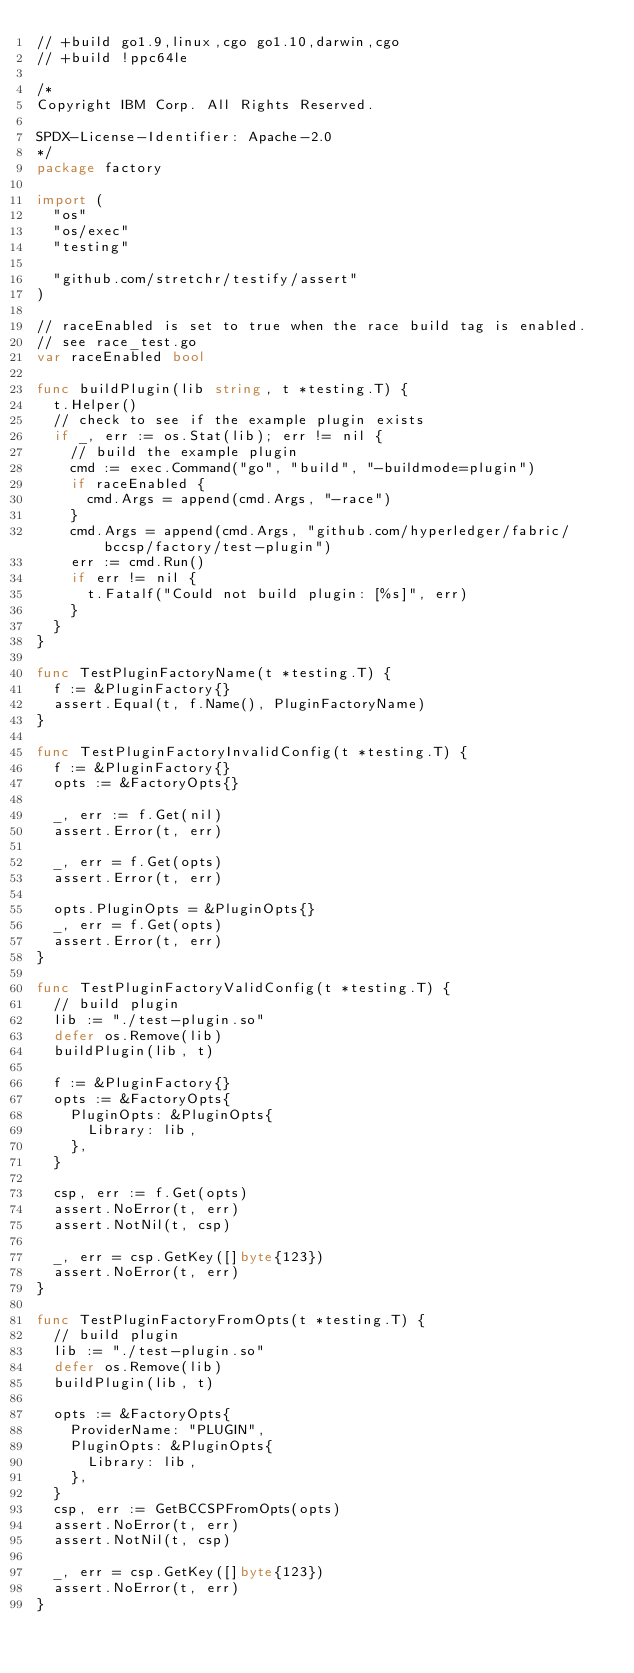<code> <loc_0><loc_0><loc_500><loc_500><_Go_>// +build go1.9,linux,cgo go1.10,darwin,cgo
// +build !ppc64le

/*
Copyright IBM Corp. All Rights Reserved.

SPDX-License-Identifier: Apache-2.0
*/
package factory

import (
	"os"
	"os/exec"
	"testing"

	"github.com/stretchr/testify/assert"
)

// raceEnabled is set to true when the race build tag is enabled.
// see race_test.go
var raceEnabled bool

func buildPlugin(lib string, t *testing.T) {
	t.Helper()
	// check to see if the example plugin exists
	if _, err := os.Stat(lib); err != nil {
		// build the example plugin
		cmd := exec.Command("go", "build", "-buildmode=plugin")
		if raceEnabled {
			cmd.Args = append(cmd.Args, "-race")
		}
		cmd.Args = append(cmd.Args, "github.com/hyperledger/fabric/bccsp/factory/test-plugin")
		err := cmd.Run()
		if err != nil {
			t.Fatalf("Could not build plugin: [%s]", err)
		}
	}
}

func TestPluginFactoryName(t *testing.T) {
	f := &PluginFactory{}
	assert.Equal(t, f.Name(), PluginFactoryName)
}

func TestPluginFactoryInvalidConfig(t *testing.T) {
	f := &PluginFactory{}
	opts := &FactoryOpts{}

	_, err := f.Get(nil)
	assert.Error(t, err)

	_, err = f.Get(opts)
	assert.Error(t, err)

	opts.PluginOpts = &PluginOpts{}
	_, err = f.Get(opts)
	assert.Error(t, err)
}

func TestPluginFactoryValidConfig(t *testing.T) {
	// build plugin
	lib := "./test-plugin.so"
	defer os.Remove(lib)
	buildPlugin(lib, t)

	f := &PluginFactory{}
	opts := &FactoryOpts{
		PluginOpts: &PluginOpts{
			Library: lib,
		},
	}

	csp, err := f.Get(opts)
	assert.NoError(t, err)
	assert.NotNil(t, csp)

	_, err = csp.GetKey([]byte{123})
	assert.NoError(t, err)
}

func TestPluginFactoryFromOpts(t *testing.T) {
	// build plugin
	lib := "./test-plugin.so"
	defer os.Remove(lib)
	buildPlugin(lib, t)

	opts := &FactoryOpts{
		ProviderName: "PLUGIN",
		PluginOpts: &PluginOpts{
			Library: lib,
		},
	}
	csp, err := GetBCCSPFromOpts(opts)
	assert.NoError(t, err)
	assert.NotNil(t, csp)

	_, err = csp.GetKey([]byte{123})
	assert.NoError(t, err)
}
</code> 